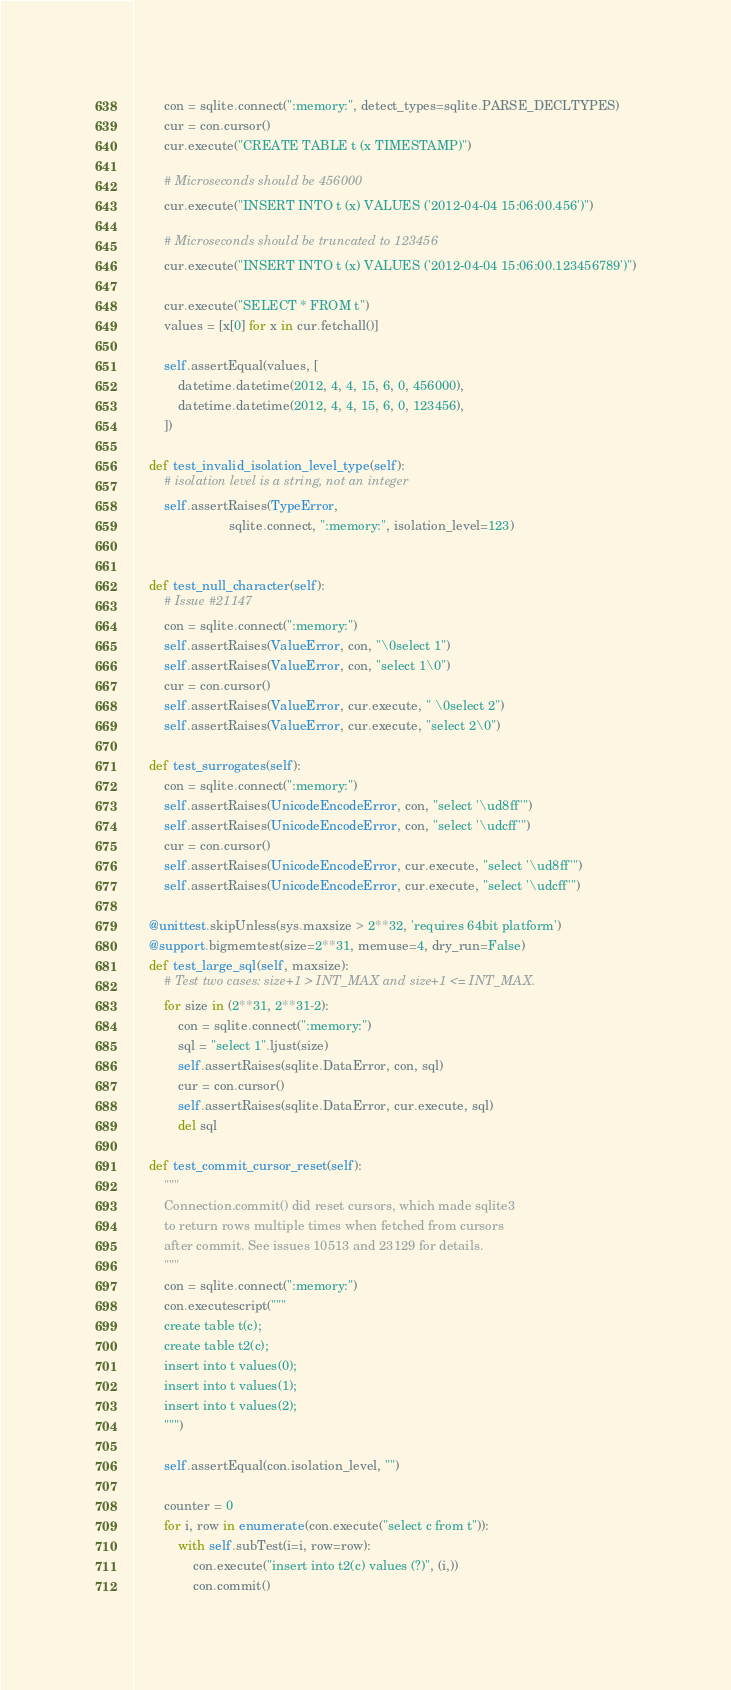<code> <loc_0><loc_0><loc_500><loc_500><_Python_>
        con = sqlite.connect(":memory:", detect_types=sqlite.PARSE_DECLTYPES)
        cur = con.cursor()
        cur.execute("CREATE TABLE t (x TIMESTAMP)")

        # Microseconds should be 456000
        cur.execute("INSERT INTO t (x) VALUES ('2012-04-04 15:06:00.456')")

        # Microseconds should be truncated to 123456
        cur.execute("INSERT INTO t (x) VALUES ('2012-04-04 15:06:00.123456789')")

        cur.execute("SELECT * FROM t")
        values = [x[0] for x in cur.fetchall()]

        self.assertEqual(values, [
            datetime.datetime(2012, 4, 4, 15, 6, 0, 456000),
            datetime.datetime(2012, 4, 4, 15, 6, 0, 123456),
        ])

    def test_invalid_isolation_level_type(self):
        # isolation level is a string, not an integer
        self.assertRaises(TypeError,
                          sqlite.connect, ":memory:", isolation_level=123)


    def test_null_character(self):
        # Issue #21147
        con = sqlite.connect(":memory:")
        self.assertRaises(ValueError, con, "\0select 1")
        self.assertRaises(ValueError, con, "select 1\0")
        cur = con.cursor()
        self.assertRaises(ValueError, cur.execute, " \0select 2")
        self.assertRaises(ValueError, cur.execute, "select 2\0")

    def test_surrogates(self):
        con = sqlite.connect(":memory:")
        self.assertRaises(UnicodeEncodeError, con, "select '\ud8ff'")
        self.assertRaises(UnicodeEncodeError, con, "select '\udcff'")
        cur = con.cursor()
        self.assertRaises(UnicodeEncodeError, cur.execute, "select '\ud8ff'")
        self.assertRaises(UnicodeEncodeError, cur.execute, "select '\udcff'")

    @unittest.skipUnless(sys.maxsize > 2**32, 'requires 64bit platform')
    @support.bigmemtest(size=2**31, memuse=4, dry_run=False)
    def test_large_sql(self, maxsize):
        # Test two cases: size+1 > INT_MAX and size+1 <= INT_MAX.
        for size in (2**31, 2**31-2):
            con = sqlite.connect(":memory:")
            sql = "select 1".ljust(size)
            self.assertRaises(sqlite.DataError, con, sql)
            cur = con.cursor()
            self.assertRaises(sqlite.DataError, cur.execute, sql)
            del sql

    def test_commit_cursor_reset(self):
        """
        Connection.commit() did reset cursors, which made sqlite3
        to return rows multiple times when fetched from cursors
        after commit. See issues 10513 and 23129 for details.
        """
        con = sqlite.connect(":memory:")
        con.executescript("""
        create table t(c);
        create table t2(c);
        insert into t values(0);
        insert into t values(1);
        insert into t values(2);
        """)

        self.assertEqual(con.isolation_level, "")

        counter = 0
        for i, row in enumerate(con.execute("select c from t")):
            with self.subTest(i=i, row=row):
                con.execute("insert into t2(c) values (?)", (i,))
                con.commit()</code> 